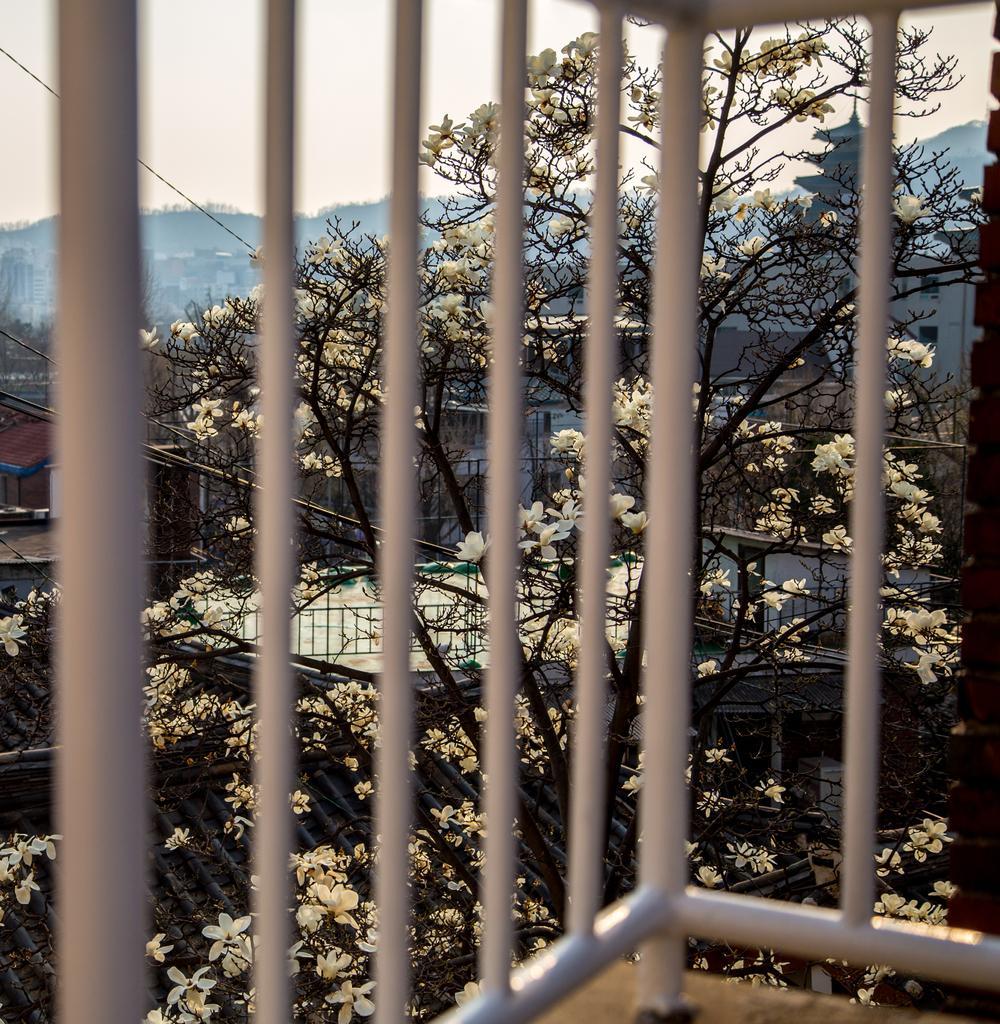Please provide a concise description of this image. This image is taken outdoors. At the top of the image there is the sky. In the background there are a few trees. There are many buildings and houses. There is a tree with flowers, stems and branches. In the middle of the image there is a railing. At the bottom of the image there is a floor. 